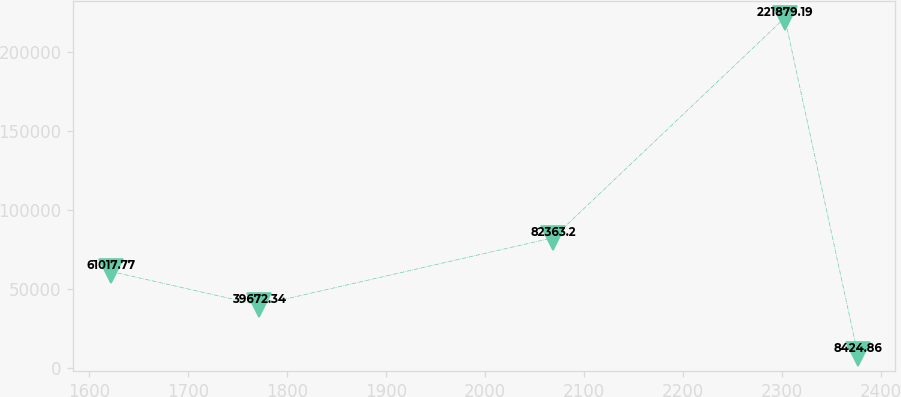Convert chart to OTSL. <chart><loc_0><loc_0><loc_500><loc_500><line_chart><ecel><fcel>Unnamed: 1<nl><fcel>1621.62<fcel>61017.8<nl><fcel>1771.53<fcel>39672.3<nl><fcel>2068.66<fcel>82363.2<nl><fcel>2302.55<fcel>221879<nl><fcel>2376.39<fcel>8424.86<nl></chart> 